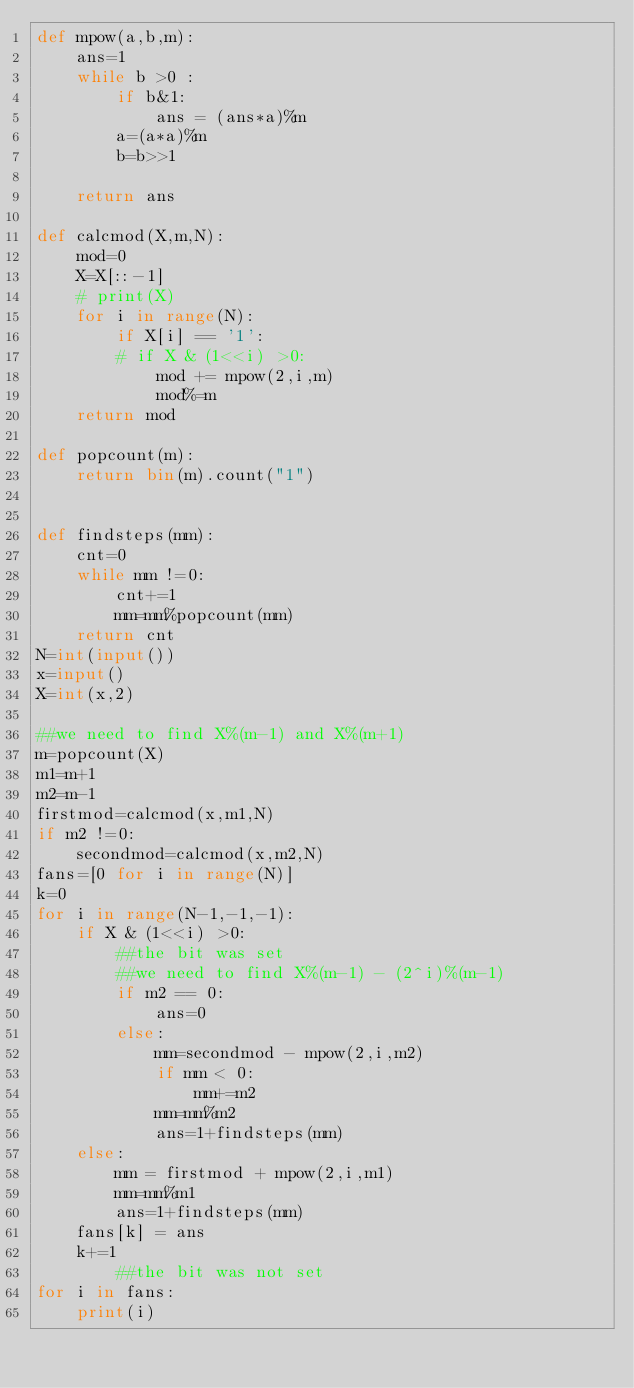Convert code to text. <code><loc_0><loc_0><loc_500><loc_500><_Python_>def mpow(a,b,m):
    ans=1
    while b >0 :
        if b&1:
            ans = (ans*a)%m
        a=(a*a)%m
        b=b>>1

    return ans

def calcmod(X,m,N):
    mod=0
    X=X[::-1]
    # print(X)
    for i in range(N):
        if X[i] == '1':
        # if X & (1<<i) >0:
            mod += mpow(2,i,m)
            mod%=m
    return mod

def popcount(m):
    return bin(m).count("1")


def findsteps(mm):
    cnt=0
    while mm !=0:
        cnt+=1
        mm=mm%popcount(mm)
    return cnt
N=int(input())
x=input()
X=int(x,2)

##we need to find X%(m-1) and X%(m+1)
m=popcount(X)
m1=m+1
m2=m-1
firstmod=calcmod(x,m1,N)
if m2 !=0:
    secondmod=calcmod(x,m2,N)
fans=[0 for i in range(N)]
k=0
for i in range(N-1,-1,-1):
    if X & (1<<i) >0:
        ##the bit was set
        ##we need to find X%(m-1) - (2^i)%(m-1)
        if m2 == 0:
            ans=0
        else:
            mm=secondmod - mpow(2,i,m2)
            if mm < 0:
                mm+=m2
            mm=mm%m2
            ans=1+findsteps(mm)
    else:
        mm = firstmod + mpow(2,i,m1)
        mm=mm%m1
        ans=1+findsteps(mm)
    fans[k] = ans
    k+=1
        ##the bit was not set
for i in fans:
    print(i)</code> 